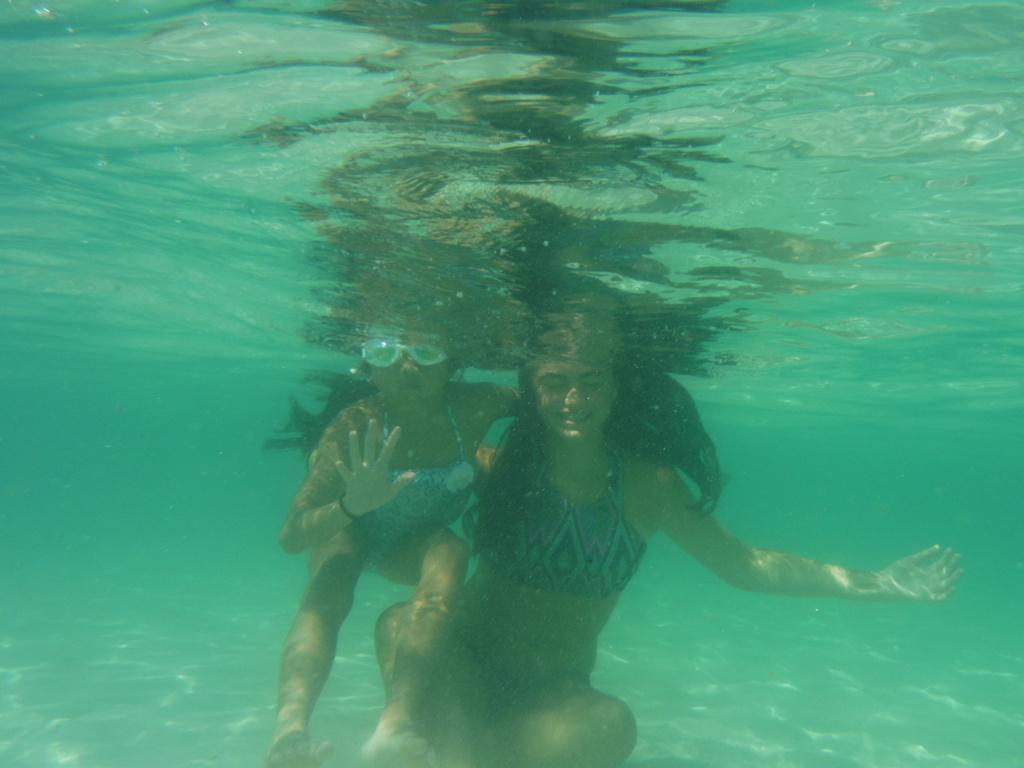How many people are in the image? There are two women in the image. What are the women doing in the image? The women are inside the water. What protective gear are the women wearing? The women are wearing goggles. What is the facial expression of the women in the image? The women are smiling. What type of school can be seen in the background of the image? There is no school visible in the image; it features two women inside the water wearing goggles and smiling. Can you tell me the name of the minister who is present in the image? There is no minister present in the image. 